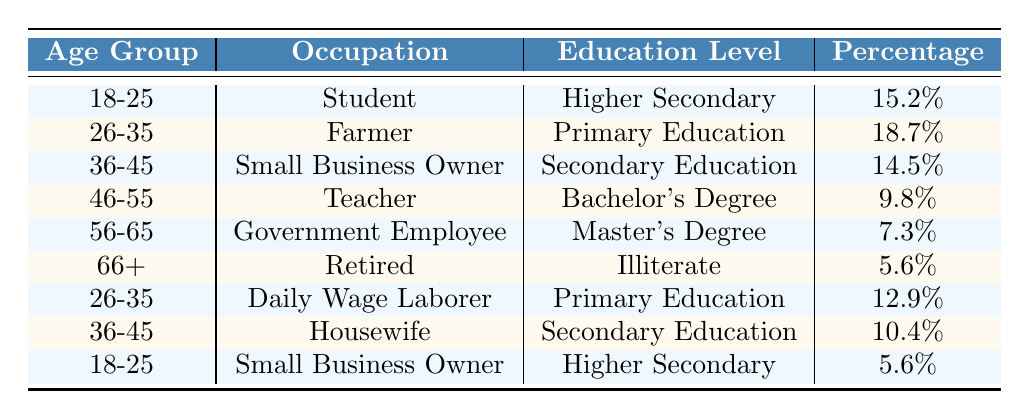What percentage of supporters are students aged 18-25? Referring to the table, the percentage of supporters who are students in the age group 18-25 is 15.2%.
Answer: 15.2% Which occupation has the highest percentage of supporters aged 26-35? The table shows that the "Farmer" occupation has the highest percentage (18.7%) among supporters aged 26-35.
Answer: Farmer What is the total percentage of supporters in the age group 36-45? Adding together the percentages for age group 36-45, we have 14.5% (Small Business Owner) + 10.4% (Housewife) = 24.9%.
Answer: 24.9% Is the majority of supporters aged 56-65 highly educated? The table indicates that 7.3% are government employees with a Master's degree, which is the highest education level in this group, thus the majority are not highly educated.
Answer: No How does the percentage of Daily Wage Laborers aged 26-35 compare to Small Business Owners aged 36-45? The percentage for Daily Wage Laborers aged 26-35 is 12.9%, while for Small Business Owners aged 36-45 it is 14.5%. Therefore, 14.5% > 12.9%.
Answer: 14.5% is higher What occupation among supporters aged 46-55 has the highest education level? The table indicates that the occupation of Teacher has a Bachelor's Degree, which is the highest education level listed for age group 46-55.
Answer: Teacher If we consider all age groups, what is the education level of the least represented occupation? Among all occupations listed, "Retired" has the least percentage of 5.6%, and they are identified as Illiterate.
Answer: Illiterate What is the average percentage of supporters across all age groups in the "Higher Secondary" education level? Summing up the percentages for "Higher Secondary" education gives 15.2% (Student, 18-25) + 5.6% (Small Business Owner, 18-25) = 20.8%, dividing by 2 gives an average of 10.4%.
Answer: 10.4% Which age group has the least percentage of supporters? The age group with the least percentage is 66+ with 5.6%.
Answer: 66+ What can be inferred about the educational background of supporters aged 36-45? The data shows that supporters aged 36-45 have occupations associated with secondary education, indicating a moderate level of education.
Answer: Moderate education What is the total percentage of supporters who have a Bachelor's Degree? The total happens to be 9.8%, which corresponds specifically to the Teacher occupation in the age group 46-55.
Answer: 9.8% 